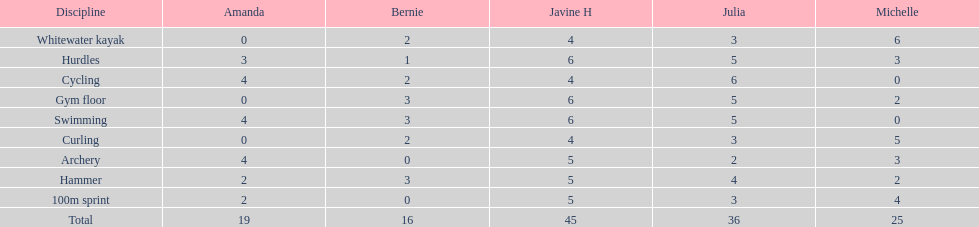What is the primary discipline presented on this chart? Whitewater kayak. 